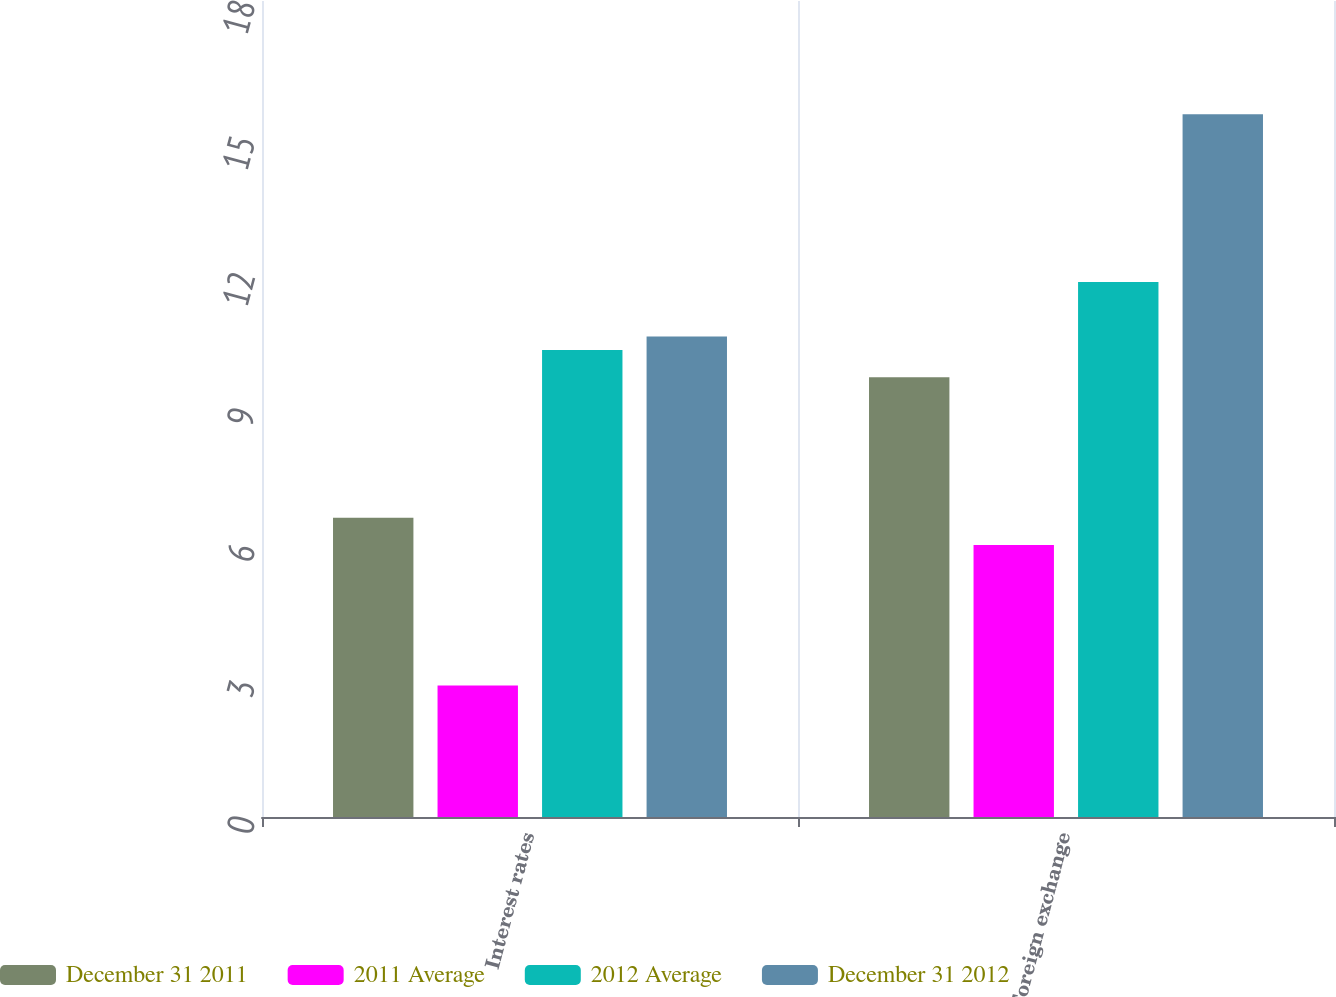Convert chart. <chart><loc_0><loc_0><loc_500><loc_500><stacked_bar_chart><ecel><fcel>Interest rates<fcel>Foreign exchange<nl><fcel>December 31 2011<fcel>6.6<fcel>9.7<nl><fcel>2011 Average<fcel>2.9<fcel>6<nl><fcel>2012 Average<fcel>10.3<fcel>11.8<nl><fcel>December 31 2012<fcel>10.6<fcel>15.5<nl></chart> 